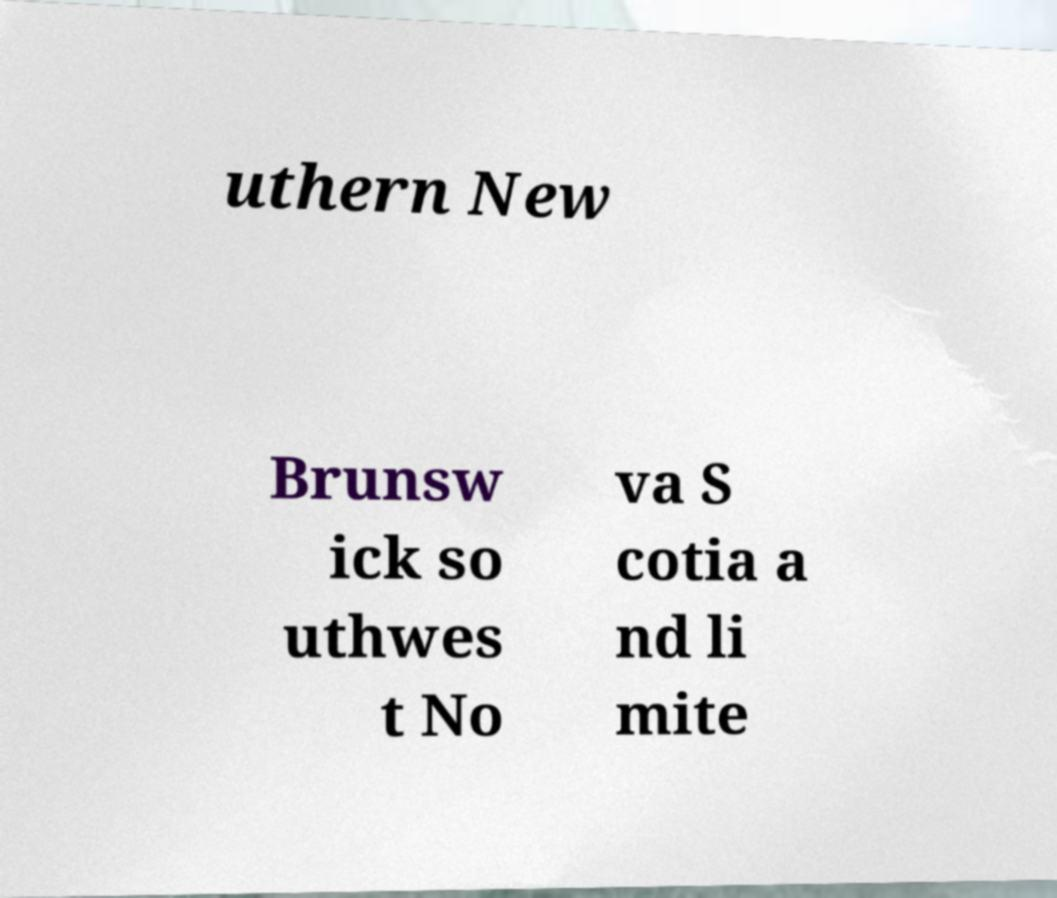Could you assist in decoding the text presented in this image and type it out clearly? uthern New Brunsw ick so uthwes t No va S cotia a nd li mite 